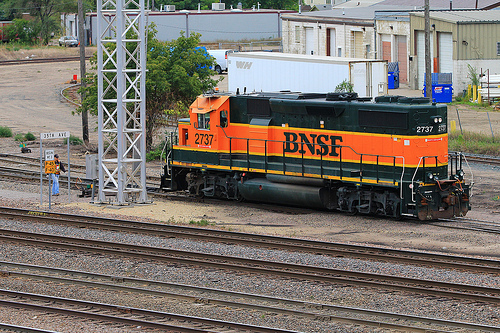What details can you tell me about the locomotive itself? The locomotive is a diesel-electric model, as indicated by the presence of fuel tanks beneath its frame, with a BNSF Railway paint scheme. Its number is 2737, which can be specific to its model and the fleet it belongs to. 